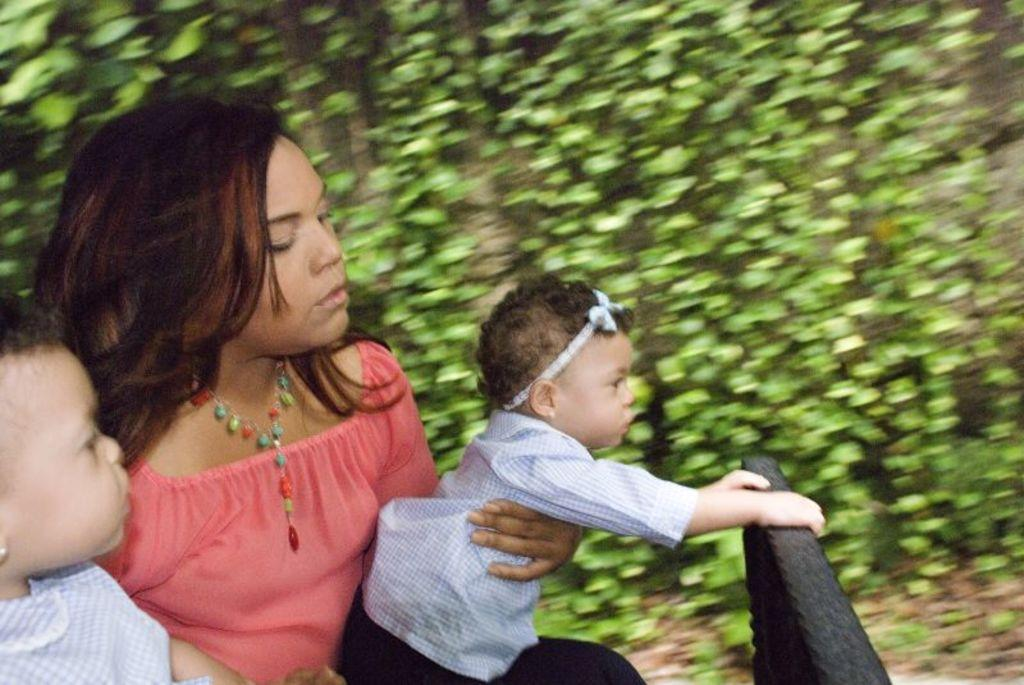Who is on the left side of the image? There is a woman on the left side of the image. What is the woman doing in the image? The woman is holding two kids in the image. What can be seen in the background of the image? There are plants visible in the background of the image. What type of scissors can be seen in the image? There are no scissors present in the image. How does the boy in the image turn around? There is no boy present in the image; it features a woman holding two kids. 